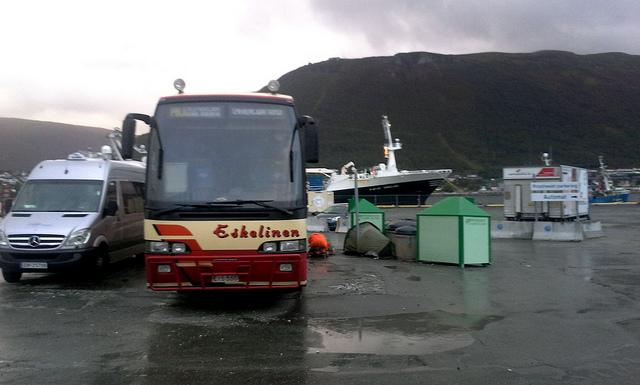What has caused the puddle in front of the bus?

Choices:
A) flooding
B) rain
C) snow
D) hose rain 